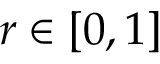<formula> <loc_0><loc_0><loc_500><loc_500>r \in [ 0 , 1 ]</formula> 